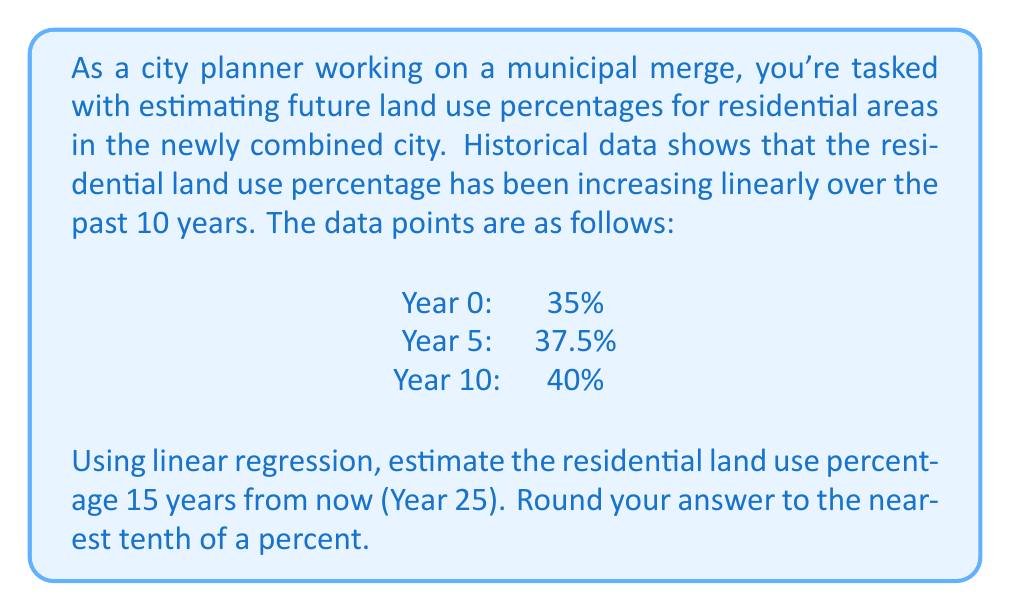Help me with this question. To solve this problem, we'll use linear regression to find the line of best fit and then use that line to predict the future land use percentage.

1. First, let's identify our points:
   $(0, 35)$, $(5, 37.5)$, $(10, 40)$

2. To find the slope of the line, we'll use the first and last points:
   $m = \frac{y_2 - y_1}{x_2 - x_1} = \frac{40 - 35}{10 - 0} = \frac{5}{10} = 0.5$

3. Now we can use the point-slope form of a line to find the equation:
   $y - y_1 = m(x - x_1)$
   $y - 35 = 0.5(x - 0)$
   $y = 0.5x + 35$

4. This is our linear regression equation. To find the percentage at Year 25, we substitute $x = 25$:
   $y = 0.5(25) + 35 = 12.5 + 35 = 47.5$

Therefore, the estimated residential land use percentage 15 years from now (Year 25) is 47.5%.

We can verify this result by checking that it fits the given data points:
For Year 0: $y = 0.5(0) + 35 = 35$
For Year 5: $y = 0.5(5) + 35 = 37.5$
For Year 10: $y = 0.5(10) + 35 = 40$

These all match the given data, confirming our linear regression is correct.
Answer: 47.5% 